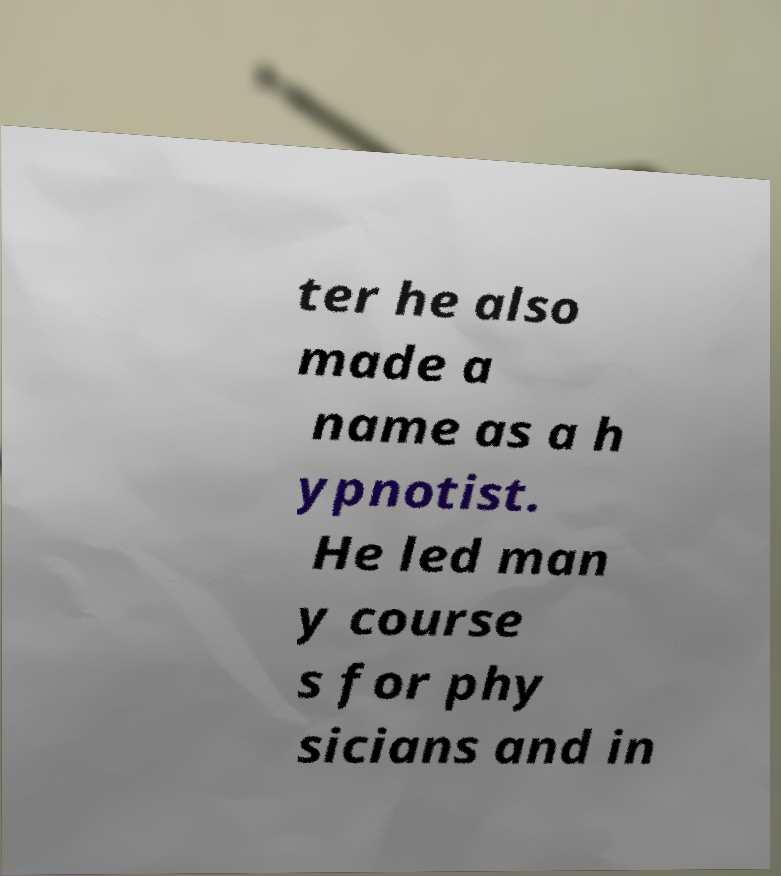Can you accurately transcribe the text from the provided image for me? ter he also made a name as a h ypnotist. He led man y course s for phy sicians and in 